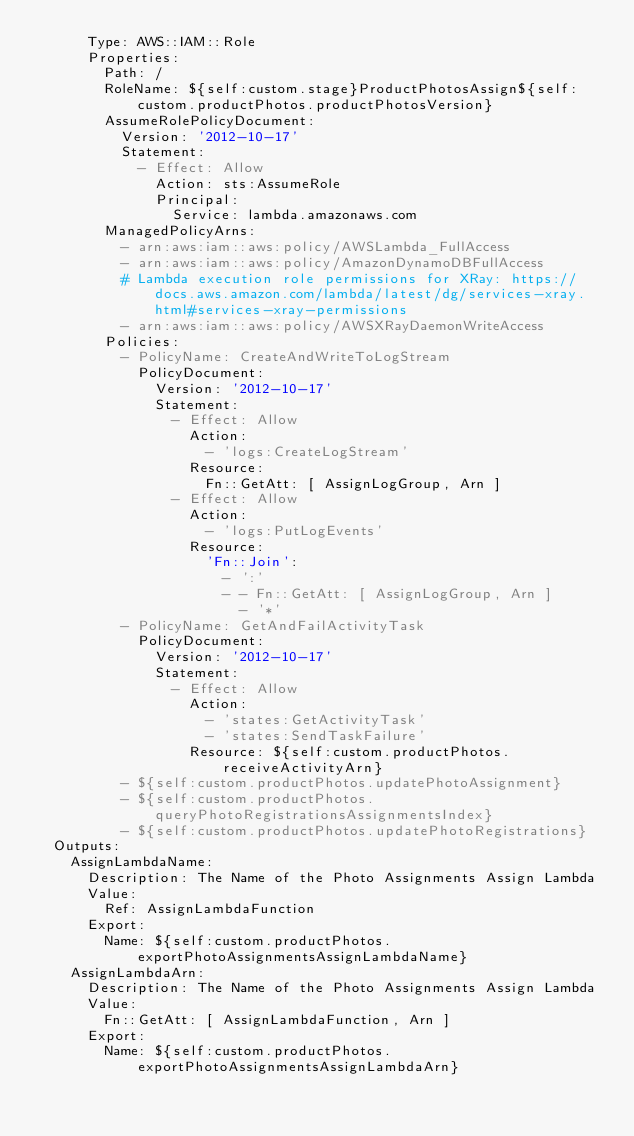<code> <loc_0><loc_0><loc_500><loc_500><_YAML_>      Type: AWS::IAM::Role
      Properties:
        Path: /
        RoleName: ${self:custom.stage}ProductPhotosAssign${self:custom.productPhotos.productPhotosVersion}
        AssumeRolePolicyDocument:
          Version: '2012-10-17'
          Statement:
            - Effect: Allow
              Action: sts:AssumeRole
              Principal:
                Service: lambda.amazonaws.com
        ManagedPolicyArns:
          - arn:aws:iam::aws:policy/AWSLambda_FullAccess
          - arn:aws:iam::aws:policy/AmazonDynamoDBFullAccess
          # Lambda execution role permissions for XRay: https://docs.aws.amazon.com/lambda/latest/dg/services-xray.html#services-xray-permissions
          - arn:aws:iam::aws:policy/AWSXRayDaemonWriteAccess
        Policies:
          - PolicyName: CreateAndWriteToLogStream
            PolicyDocument:
              Version: '2012-10-17'
              Statement:
                - Effect: Allow
                  Action:
                    - 'logs:CreateLogStream'
                  Resource:
                    Fn::GetAtt: [ AssignLogGroup, Arn ]
                - Effect: Allow
                  Action:
                    - 'logs:PutLogEvents'
                  Resource:
                    'Fn::Join':
                      - ':'
                      - - Fn::GetAtt: [ AssignLogGroup, Arn ]
                        - '*'
          - PolicyName: GetAndFailActivityTask
            PolicyDocument:
              Version: '2012-10-17'
              Statement:
                - Effect: Allow
                  Action:
                    - 'states:GetActivityTask'
                    - 'states:SendTaskFailure'
                  Resource: ${self:custom.productPhotos.receiveActivityArn}
          - ${self:custom.productPhotos.updatePhotoAssignment}
          - ${self:custom.productPhotos.queryPhotoRegistrationsAssignmentsIndex}
          - ${self:custom.productPhotos.updatePhotoRegistrations}
  Outputs:
    AssignLambdaName:
      Description: The Name of the Photo Assignments Assign Lambda
      Value:
        Ref: AssignLambdaFunction
      Export:
        Name: ${self:custom.productPhotos.exportPhotoAssignmentsAssignLambdaName}
    AssignLambdaArn:
      Description: The Name of the Photo Assignments Assign Lambda
      Value:
        Fn::GetAtt: [ AssignLambdaFunction, Arn ]
      Export:
        Name: ${self:custom.productPhotos.exportPhotoAssignmentsAssignLambdaArn}
</code> 